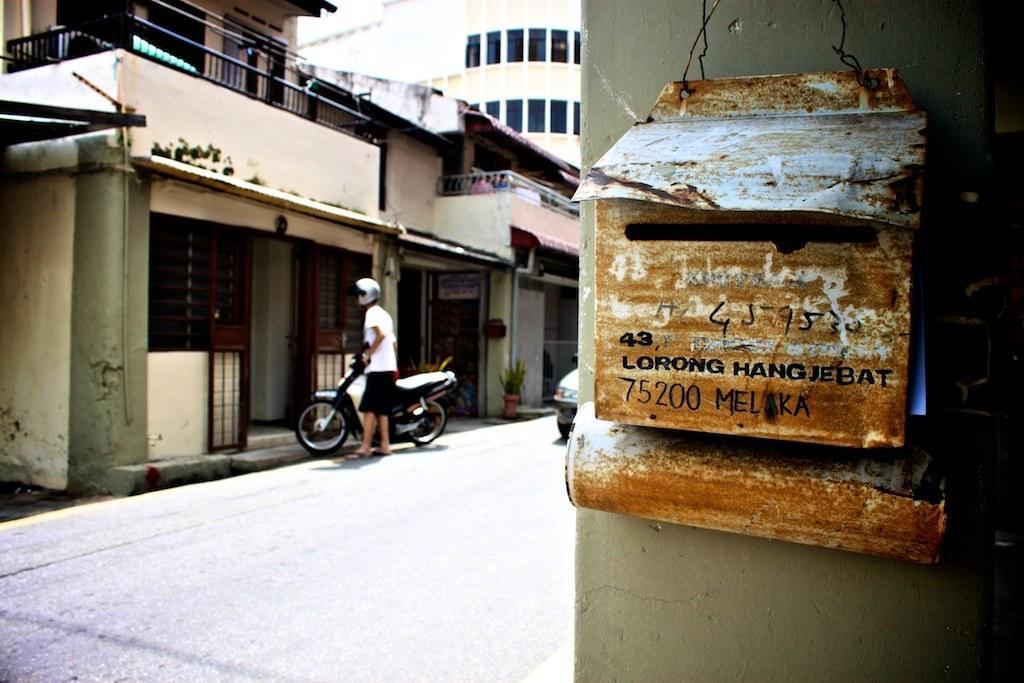Please provide a concise description of this image. On the right side of this image there is a post box attached to the wall. On the left side there is a road and there is a vehicle. One person is wearing a helmet, holding a motorcycle and standing facing towards the left side. In the background there are few buildings. 